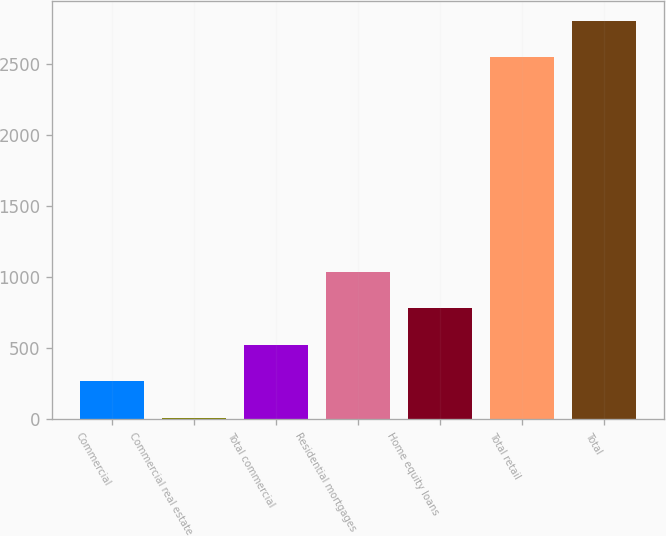Convert chart to OTSL. <chart><loc_0><loc_0><loc_500><loc_500><bar_chart><fcel>Commercial<fcel>Commercial real estate<fcel>Total commercial<fcel>Residential mortgages<fcel>Home equity loans<fcel>Total retail<fcel>Total<nl><fcel>266.2<fcel>9<fcel>523.4<fcel>1037.8<fcel>780.6<fcel>2547<fcel>2804.2<nl></chart> 